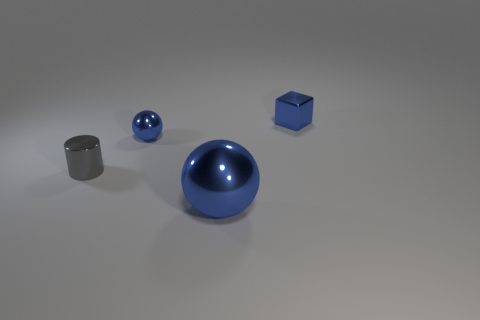What is the tiny gray thing made of? metal 